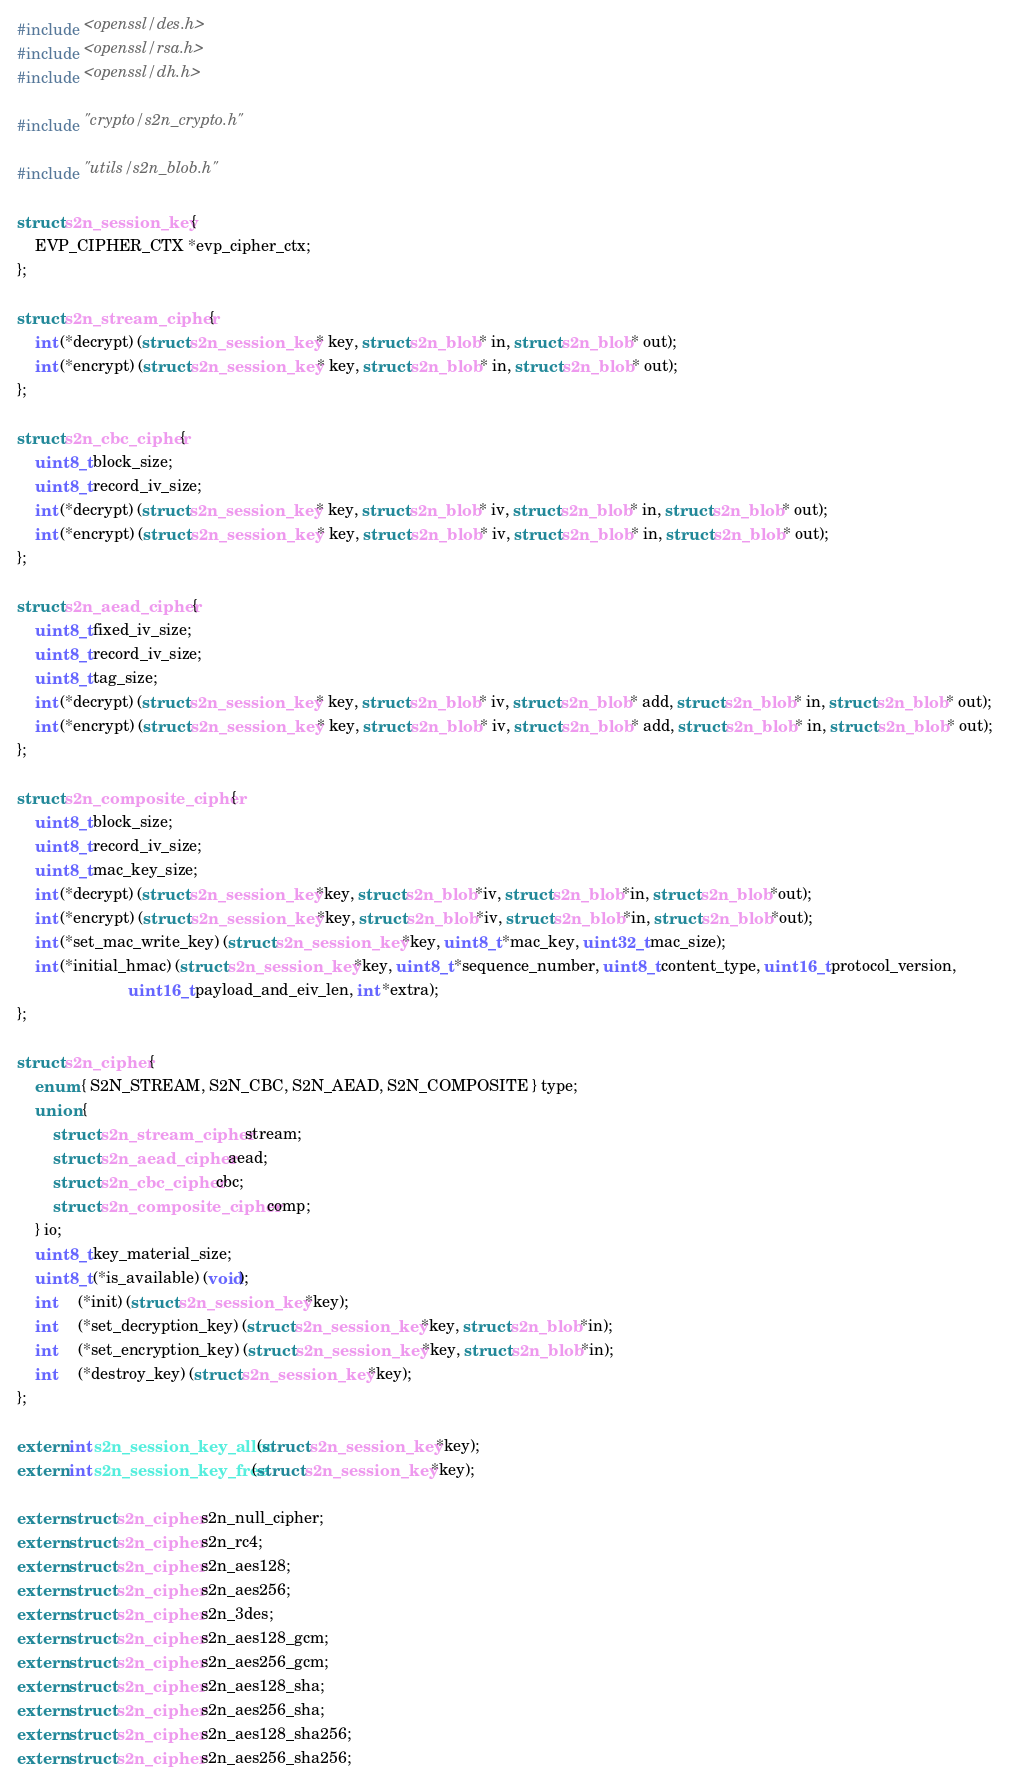Convert code to text. <code><loc_0><loc_0><loc_500><loc_500><_C_>#include <openssl/des.h>
#include <openssl/rsa.h>
#include <openssl/dh.h>

#include "crypto/s2n_crypto.h"

#include "utils/s2n_blob.h"

struct s2n_session_key {
    EVP_CIPHER_CTX *evp_cipher_ctx;
};

struct s2n_stream_cipher {
    int (*decrypt) (struct s2n_session_key * key, struct s2n_blob * in, struct s2n_blob * out);
    int (*encrypt) (struct s2n_session_key * key, struct s2n_blob * in, struct s2n_blob * out);
};

struct s2n_cbc_cipher {
    uint8_t block_size;
    uint8_t record_iv_size;
    int (*decrypt) (struct s2n_session_key * key, struct s2n_blob * iv, struct s2n_blob * in, struct s2n_blob * out);
    int (*encrypt) (struct s2n_session_key * key, struct s2n_blob * iv, struct s2n_blob * in, struct s2n_blob * out);
};

struct s2n_aead_cipher {
    uint8_t fixed_iv_size;
    uint8_t record_iv_size;
    uint8_t tag_size;
    int (*decrypt) (struct s2n_session_key * key, struct s2n_blob * iv, struct s2n_blob * add, struct s2n_blob * in, struct s2n_blob * out);
    int (*encrypt) (struct s2n_session_key * key, struct s2n_blob * iv, struct s2n_blob * add, struct s2n_blob * in, struct s2n_blob * out);
};

struct s2n_composite_cipher {
    uint8_t block_size;
    uint8_t record_iv_size;
    uint8_t mac_key_size;
    int (*decrypt) (struct s2n_session_key *key, struct s2n_blob *iv, struct s2n_blob *in, struct s2n_blob *out);
    int (*encrypt) (struct s2n_session_key *key, struct s2n_blob *iv, struct s2n_blob *in, struct s2n_blob *out);
    int (*set_mac_write_key) (struct s2n_session_key *key, uint8_t *mac_key, uint32_t mac_size);
    int (*initial_hmac) (struct s2n_session_key *key, uint8_t *sequence_number, uint8_t content_type, uint16_t protocol_version,
                         uint16_t payload_and_eiv_len, int *extra);
};

struct s2n_cipher {
    enum { S2N_STREAM, S2N_CBC, S2N_AEAD, S2N_COMPOSITE } type;
    union {
        struct s2n_stream_cipher stream;
        struct s2n_aead_cipher aead;
        struct s2n_cbc_cipher cbc;
        struct s2n_composite_cipher comp;
    } io;
    uint8_t key_material_size;
    uint8_t (*is_available) (void);
    int     (*init) (struct s2n_session_key *key);
    int     (*set_decryption_key) (struct s2n_session_key *key, struct s2n_blob *in);
    int     (*set_encryption_key) (struct s2n_session_key *key, struct s2n_blob *in);
    int     (*destroy_key) (struct s2n_session_key *key);
};

extern int s2n_session_key_alloc(struct s2n_session_key *key);
extern int s2n_session_key_free(struct s2n_session_key *key);

extern struct s2n_cipher s2n_null_cipher;
extern struct s2n_cipher s2n_rc4;
extern struct s2n_cipher s2n_aes128;
extern struct s2n_cipher s2n_aes256;
extern struct s2n_cipher s2n_3des;
extern struct s2n_cipher s2n_aes128_gcm;
extern struct s2n_cipher s2n_aes256_gcm;
extern struct s2n_cipher s2n_aes128_sha;
extern struct s2n_cipher s2n_aes256_sha;
extern struct s2n_cipher s2n_aes128_sha256;
extern struct s2n_cipher s2n_aes256_sha256;

</code> 